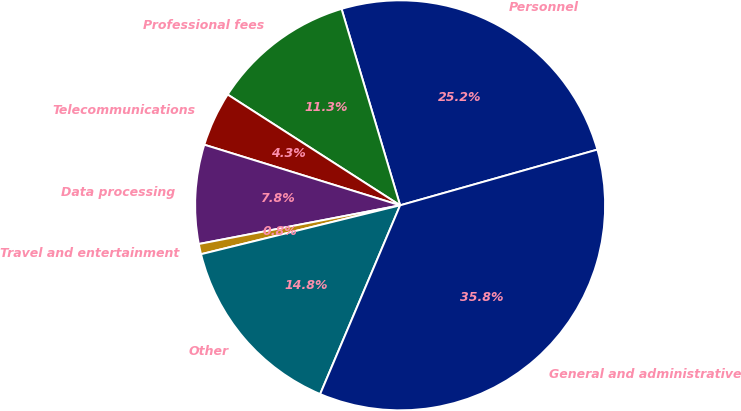<chart> <loc_0><loc_0><loc_500><loc_500><pie_chart><fcel>Personnel<fcel>Professional fees<fcel>Telecommunications<fcel>Data processing<fcel>Travel and entertainment<fcel>Other<fcel>General and administrative<nl><fcel>25.23%<fcel>11.3%<fcel>4.31%<fcel>7.8%<fcel>0.81%<fcel>14.79%<fcel>35.76%<nl></chart> 